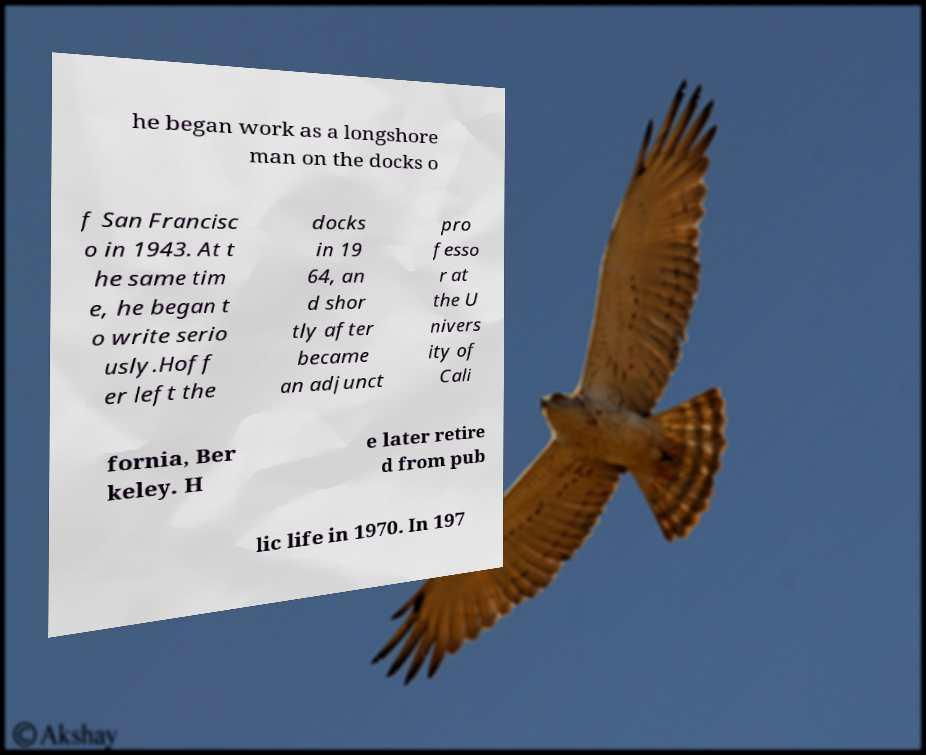What messages or text are displayed in this image? I need them in a readable, typed format. he began work as a longshore man on the docks o f San Francisc o in 1943. At t he same tim e, he began t o write serio usly.Hoff er left the docks in 19 64, an d shor tly after became an adjunct pro fesso r at the U nivers ity of Cali fornia, Ber keley. H e later retire d from pub lic life in 1970. In 197 